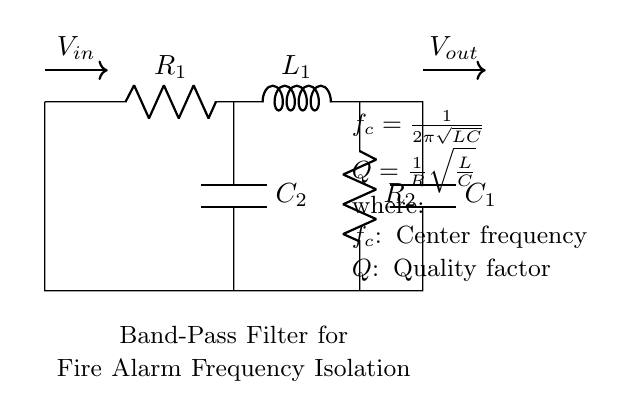What is the input voltage source in this circuit? The input voltage source is denoted as \( V_{in} \), which is marked with an arrow indicating the direction of current flow into the circuit.
Answer: V_in What types of components are present in this circuit? The circuit consists of resistors, inductors, and capacitors. Specific components include \( R_1 \), \( R_2 \), \( L_1 \), \( C_1 \), and \( C_2 \).
Answer: Resistors, Inductors, Capacitors What is the center frequency formula in this circuit? The center frequency, represented by \( f_c \), is calculated using the formula \( \frac{1}{2\pi\sqrt{LC}} \) as noted in the circuit diagram.
Answer: 1/(2π√(LC)) What does the quality factor (Q) represent in this filter? The quality factor, represented by \( Q \), measures how selective a filter is and is given by \( \frac{1}{R}\sqrt{\frac{L}{C}} \) as noted in the circuit.
Answer: 1/R√(L/C) Which component isolates the desired frequency range? The inductor \( L_1 \) and capacitors \( C_1 \) and \( C_2 \) together create the band-pass filter that isolates the specific frequency range needed for fire alarm signals.
Answer: Inductor and Capacitors How does increasing resistance (R) affect the quality factor (Q)? Increasing resistance results in a lower quality factor as \( Q \) is inversely proportional to \( R \) according to the formula \( \frac{1}{R}\sqrt{\frac{L}{C}} \). This indicates decreased selectivity of the filter.
Answer: Lower Q What is the role of capacitor \( C_2 \) in this filter? Capacitor \( C_2 \) works in conjunction with other components to help define the frequency response of the filter, specifically targeting the desired frequency range needed for proper function.
Answer: Frequency response shaping 